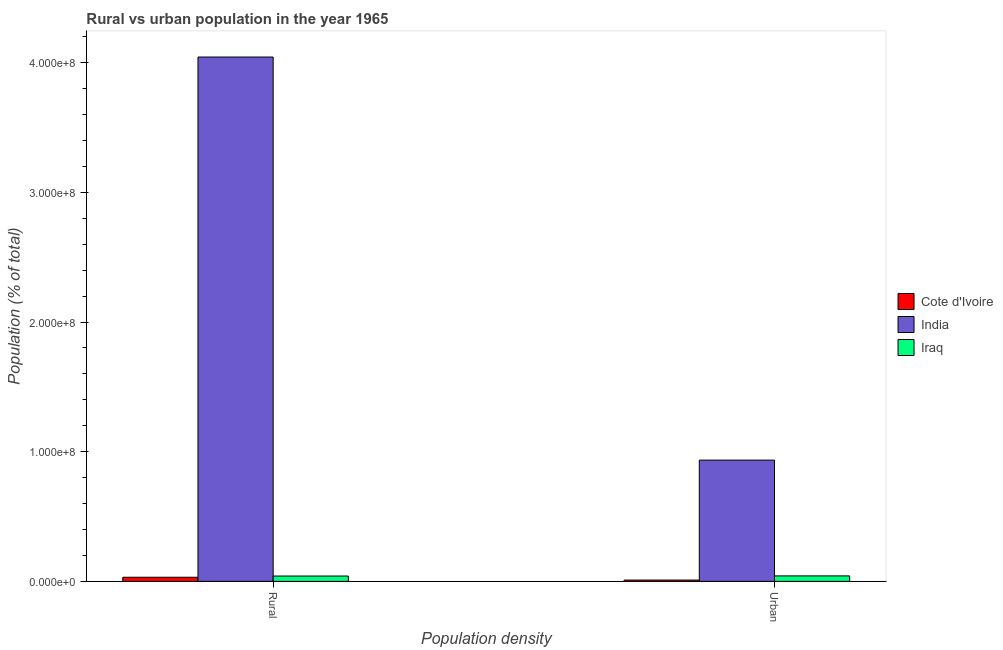How many different coloured bars are there?
Your answer should be very brief. 3. How many groups of bars are there?
Make the answer very short. 2. Are the number of bars per tick equal to the number of legend labels?
Give a very brief answer. Yes. How many bars are there on the 2nd tick from the left?
Your response must be concise. 3. What is the label of the 1st group of bars from the left?
Make the answer very short. Rural. What is the rural population density in Iraq?
Make the answer very short. 4.13e+06. Across all countries, what is the maximum urban population density?
Ensure brevity in your answer.  9.35e+07. Across all countries, what is the minimum rural population density?
Provide a short and direct response. 3.19e+06. In which country was the urban population density minimum?
Provide a short and direct response. Cote d'Ivoire. What is the total rural population density in the graph?
Your response must be concise. 4.12e+08. What is the difference between the urban population density in Iraq and that in Cote d'Ivoire?
Your answer should be compact. 3.21e+06. What is the difference between the urban population density in India and the rural population density in Cote d'Ivoire?
Offer a very short reply. 9.03e+07. What is the average urban population density per country?
Your answer should be compact. 3.29e+07. What is the difference between the urban population density and rural population density in India?
Offer a terse response. -3.11e+08. What is the ratio of the rural population density in India to that in Cote d'Ivoire?
Provide a succinct answer. 126.93. Is the rural population density in Cote d'Ivoire less than that in Iraq?
Provide a short and direct response. Yes. In how many countries, is the urban population density greater than the average urban population density taken over all countries?
Provide a succinct answer. 1. What does the 3rd bar from the left in Urban represents?
Provide a succinct answer. Iraq. What does the 3rd bar from the right in Urban represents?
Ensure brevity in your answer.  Cote d'Ivoire. Are all the bars in the graph horizontal?
Give a very brief answer. No. What is the difference between two consecutive major ticks on the Y-axis?
Ensure brevity in your answer.  1.00e+08. Are the values on the major ticks of Y-axis written in scientific E-notation?
Ensure brevity in your answer.  Yes. Where does the legend appear in the graph?
Offer a terse response. Center right. What is the title of the graph?
Provide a succinct answer. Rural vs urban population in the year 1965. Does "Virgin Islands" appear as one of the legend labels in the graph?
Offer a very short reply. No. What is the label or title of the X-axis?
Give a very brief answer. Population density. What is the label or title of the Y-axis?
Offer a terse response. Population (% of total). What is the Population (% of total) of Cote d'Ivoire in Rural?
Keep it short and to the point. 3.19e+06. What is the Population (% of total) in India in Rural?
Your response must be concise. 4.04e+08. What is the Population (% of total) in Iraq in Rural?
Give a very brief answer. 4.13e+06. What is the Population (% of total) of Cote d'Ivoire in Urban?
Your answer should be very brief. 1.03e+06. What is the Population (% of total) of India in Urban?
Provide a short and direct response. 9.35e+07. What is the Population (% of total) in Iraq in Urban?
Offer a terse response. 4.24e+06. Across all Population density, what is the maximum Population (% of total) in Cote d'Ivoire?
Keep it short and to the point. 3.19e+06. Across all Population density, what is the maximum Population (% of total) of India?
Ensure brevity in your answer.  4.04e+08. Across all Population density, what is the maximum Population (% of total) of Iraq?
Offer a terse response. 4.24e+06. Across all Population density, what is the minimum Population (% of total) of Cote d'Ivoire?
Your answer should be very brief. 1.03e+06. Across all Population density, what is the minimum Population (% of total) in India?
Your answer should be compact. 9.35e+07. Across all Population density, what is the minimum Population (% of total) in Iraq?
Offer a very short reply. 4.13e+06. What is the total Population (% of total) of Cote d'Ivoire in the graph?
Provide a short and direct response. 4.22e+06. What is the total Population (% of total) in India in the graph?
Your response must be concise. 4.98e+08. What is the total Population (% of total) in Iraq in the graph?
Your response must be concise. 8.38e+06. What is the difference between the Population (% of total) of Cote d'Ivoire in Rural and that in Urban?
Provide a short and direct response. 2.15e+06. What is the difference between the Population (% of total) in India in Rural and that in Urban?
Offer a terse response. 3.11e+08. What is the difference between the Population (% of total) in Iraq in Rural and that in Urban?
Offer a very short reply. -1.09e+05. What is the difference between the Population (% of total) of Cote d'Ivoire in Rural and the Population (% of total) of India in Urban?
Ensure brevity in your answer.  -9.03e+07. What is the difference between the Population (% of total) of Cote d'Ivoire in Rural and the Population (% of total) of Iraq in Urban?
Give a very brief answer. -1.06e+06. What is the difference between the Population (% of total) in India in Rural and the Population (% of total) in Iraq in Urban?
Offer a terse response. 4.00e+08. What is the average Population (% of total) of Cote d'Ivoire per Population density?
Offer a terse response. 2.11e+06. What is the average Population (% of total) in India per Population density?
Offer a terse response. 2.49e+08. What is the average Population (% of total) of Iraq per Population density?
Offer a very short reply. 4.19e+06. What is the difference between the Population (% of total) in Cote d'Ivoire and Population (% of total) in India in Rural?
Make the answer very short. -4.01e+08. What is the difference between the Population (% of total) of Cote d'Ivoire and Population (% of total) of Iraq in Rural?
Offer a terse response. -9.47e+05. What is the difference between the Population (% of total) of India and Population (% of total) of Iraq in Rural?
Ensure brevity in your answer.  4.00e+08. What is the difference between the Population (% of total) in Cote d'Ivoire and Population (% of total) in India in Urban?
Provide a short and direct response. -9.25e+07. What is the difference between the Population (% of total) in Cote d'Ivoire and Population (% of total) in Iraq in Urban?
Your response must be concise. -3.21e+06. What is the difference between the Population (% of total) of India and Population (% of total) of Iraq in Urban?
Offer a very short reply. 8.93e+07. What is the ratio of the Population (% of total) in Cote d'Ivoire in Rural to that in Urban?
Provide a short and direct response. 3.08. What is the ratio of the Population (% of total) in India in Rural to that in Urban?
Ensure brevity in your answer.  4.32. What is the ratio of the Population (% of total) of Iraq in Rural to that in Urban?
Make the answer very short. 0.97. What is the difference between the highest and the second highest Population (% of total) in Cote d'Ivoire?
Ensure brevity in your answer.  2.15e+06. What is the difference between the highest and the second highest Population (% of total) of India?
Offer a terse response. 3.11e+08. What is the difference between the highest and the second highest Population (% of total) of Iraq?
Offer a very short reply. 1.09e+05. What is the difference between the highest and the lowest Population (% of total) in Cote d'Ivoire?
Keep it short and to the point. 2.15e+06. What is the difference between the highest and the lowest Population (% of total) of India?
Keep it short and to the point. 3.11e+08. What is the difference between the highest and the lowest Population (% of total) in Iraq?
Offer a very short reply. 1.09e+05. 